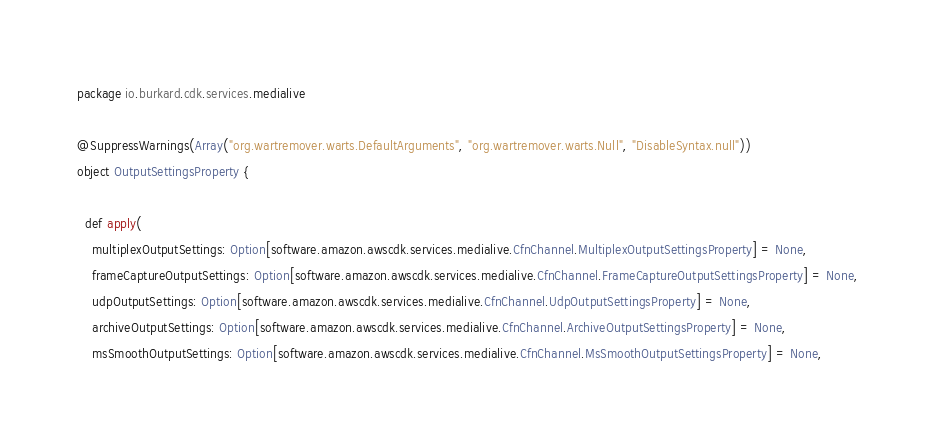Convert code to text. <code><loc_0><loc_0><loc_500><loc_500><_Scala_>package io.burkard.cdk.services.medialive

@SuppressWarnings(Array("org.wartremover.warts.DefaultArguments", "org.wartremover.warts.Null", "DisableSyntax.null"))
object OutputSettingsProperty {

  def apply(
    multiplexOutputSettings: Option[software.amazon.awscdk.services.medialive.CfnChannel.MultiplexOutputSettingsProperty] = None,
    frameCaptureOutputSettings: Option[software.amazon.awscdk.services.medialive.CfnChannel.FrameCaptureOutputSettingsProperty] = None,
    udpOutputSettings: Option[software.amazon.awscdk.services.medialive.CfnChannel.UdpOutputSettingsProperty] = None,
    archiveOutputSettings: Option[software.amazon.awscdk.services.medialive.CfnChannel.ArchiveOutputSettingsProperty] = None,
    msSmoothOutputSettings: Option[software.amazon.awscdk.services.medialive.CfnChannel.MsSmoothOutputSettingsProperty] = None,</code> 